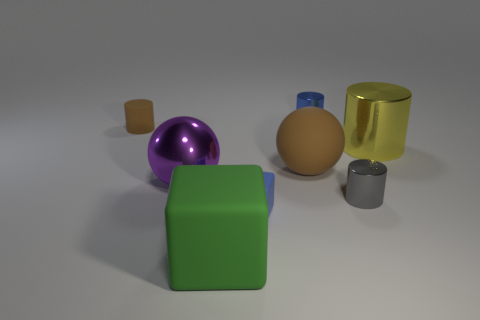There is another big object that is the same shape as the large brown rubber object; what color is it?
Make the answer very short. Purple. There is a small shiny object that is in front of the big shiny sphere; what shape is it?
Your answer should be compact. Cylinder. What number of other tiny shiny things have the same shape as the yellow metallic object?
Give a very brief answer. 2. Do the large ball that is right of the green rubber cube and the matte thing behind the yellow cylinder have the same color?
Keep it short and to the point. Yes. What number of objects are either tiny blue matte spheres or brown balls?
Keep it short and to the point. 1. What number of large brown objects have the same material as the brown cylinder?
Your answer should be very brief. 1. Are there fewer small brown metal blocks than big rubber objects?
Your answer should be very brief. Yes. Is the brown thing that is right of the green rubber cube made of the same material as the tiny block?
Your response must be concise. Yes. What number of spheres are either purple objects or large shiny things?
Offer a terse response. 1. There is a rubber thing that is both on the right side of the large purple metallic sphere and behind the tiny blue block; what shape is it?
Keep it short and to the point. Sphere. 